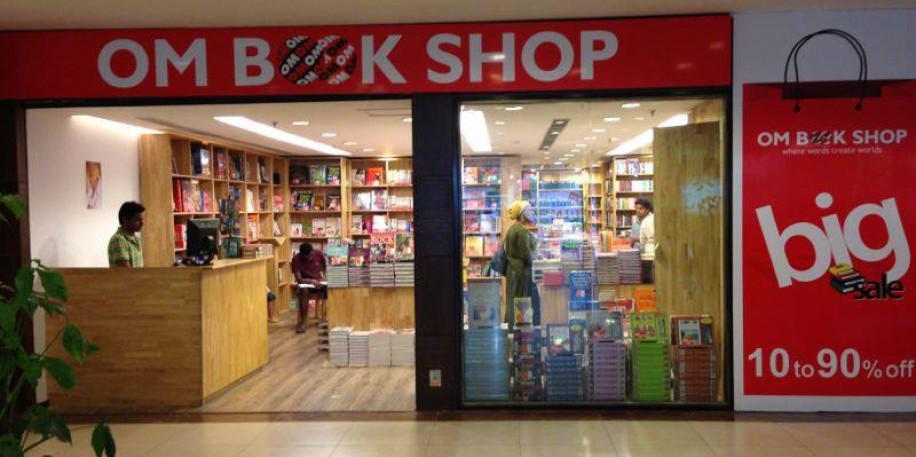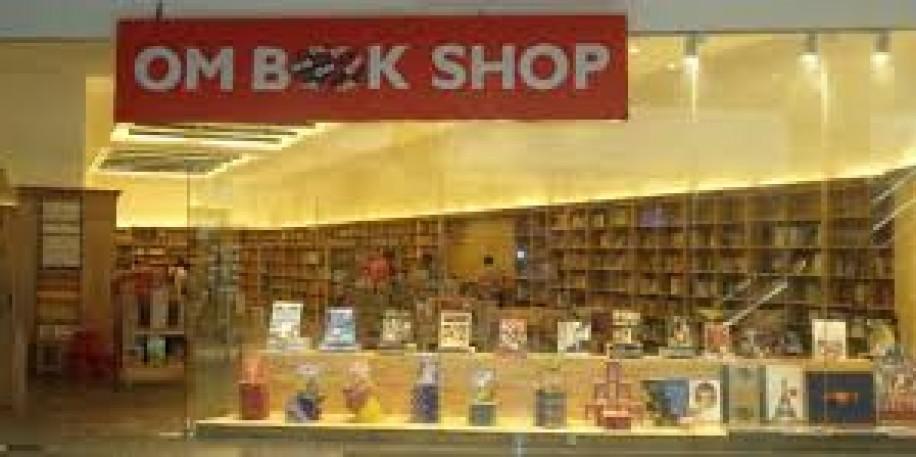The first image is the image on the left, the second image is the image on the right. Assess this claim about the two images: "Someone dressed all in black is in the center aisle of a bookstore.". Correct or not? Answer yes or no. No. 